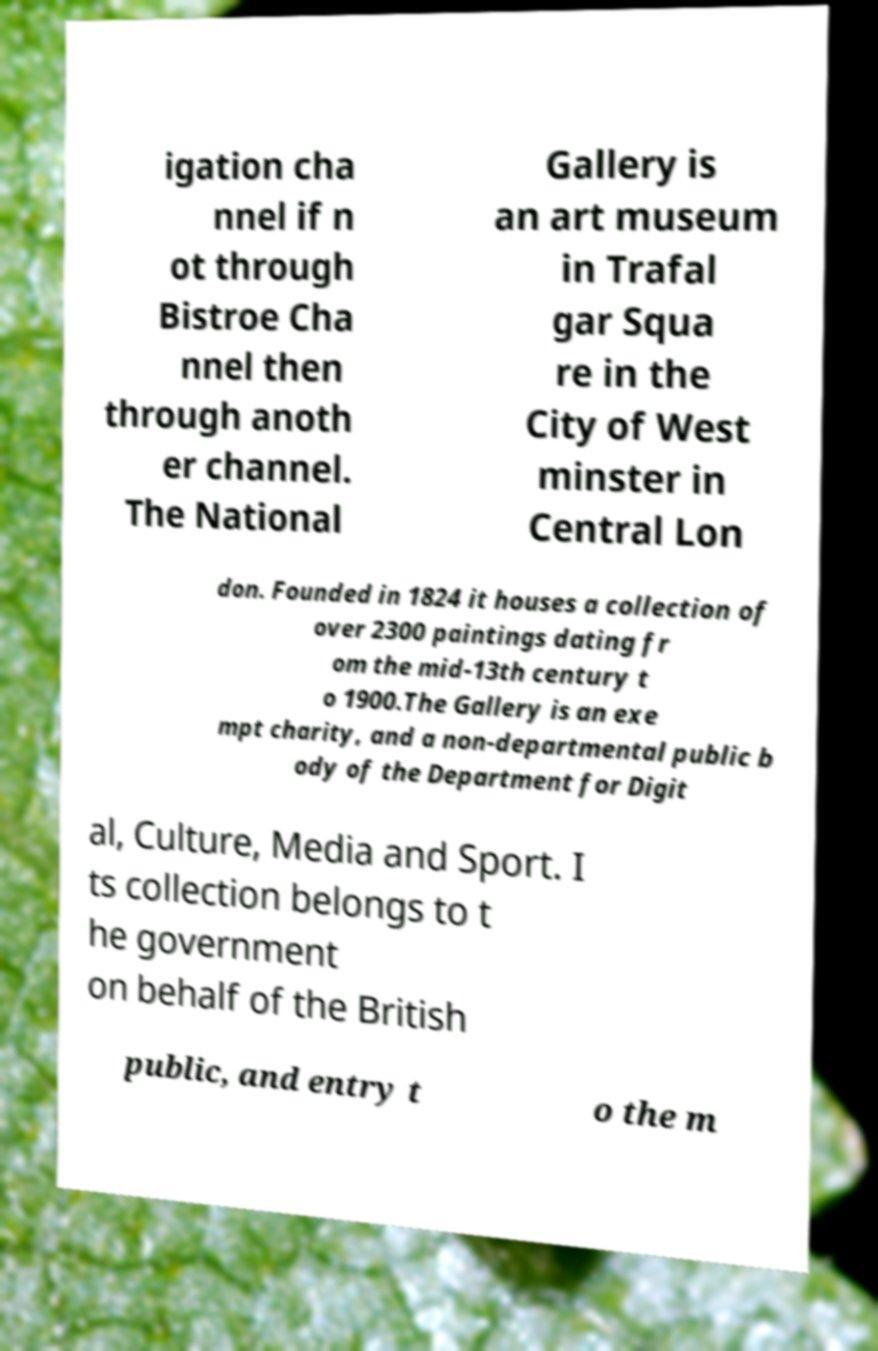Can you accurately transcribe the text from the provided image for me? igation cha nnel if n ot through Bistroe Cha nnel then through anoth er channel. The National Gallery is an art museum in Trafal gar Squa re in the City of West minster in Central Lon don. Founded in 1824 it houses a collection of over 2300 paintings dating fr om the mid-13th century t o 1900.The Gallery is an exe mpt charity, and a non-departmental public b ody of the Department for Digit al, Culture, Media and Sport. I ts collection belongs to t he government on behalf of the British public, and entry t o the m 